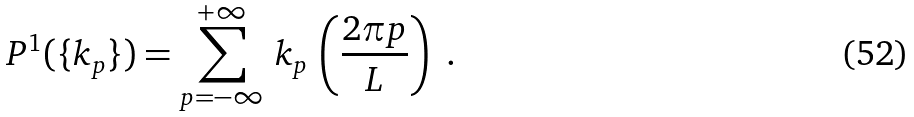Convert formula to latex. <formula><loc_0><loc_0><loc_500><loc_500>P ^ { 1 } ( \{ k _ { p } \} ) = \sum _ { p = - \infty } ^ { + \infty } \, k _ { p } \, \left ( \frac { 2 \pi p } { L } \right ) \ .</formula> 